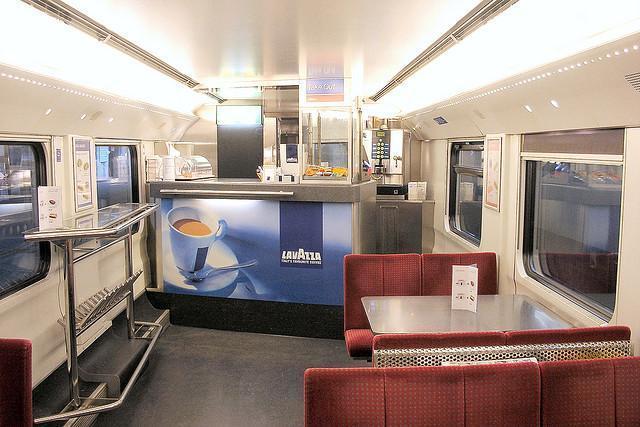How many chairs are there?
Give a very brief answer. 5. 